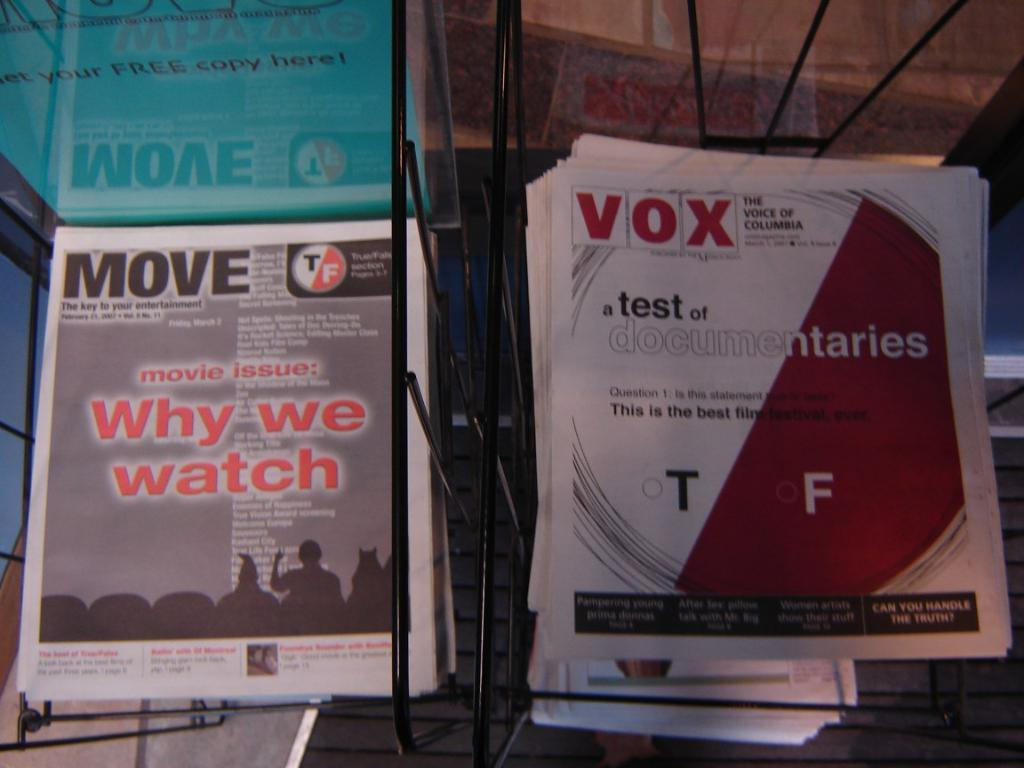<image>
Render a clear and concise summary of the photo. Newspaper racks showing stacks of MOVE and VOX newspapers. 